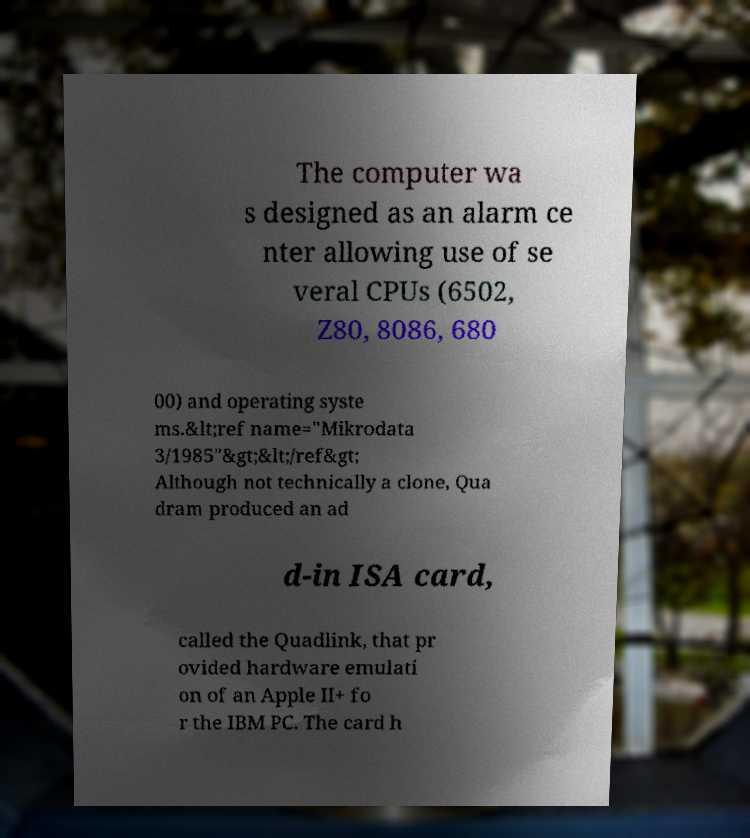What messages or text are displayed in this image? I need them in a readable, typed format. The computer wa s designed as an alarm ce nter allowing use of se veral CPUs (6502, Z80, 8086, 680 00) and operating syste ms.&lt;ref name="Mikrodata 3/1985"&gt;&lt;/ref&gt; Although not technically a clone, Qua dram produced an ad d-in ISA card, called the Quadlink, that pr ovided hardware emulati on of an Apple II+ fo r the IBM PC. The card h 